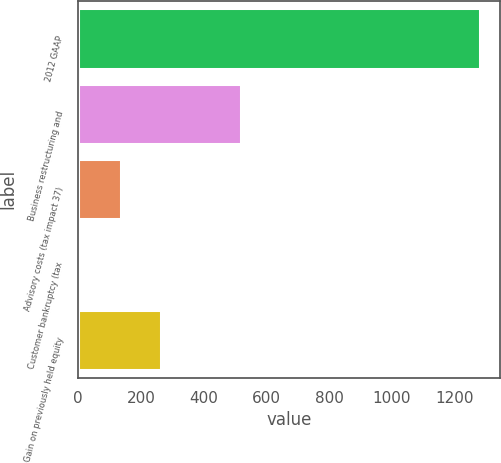Convert chart. <chart><loc_0><loc_0><loc_500><loc_500><bar_chart><fcel>2012 GAAP<fcel>Business restructuring and<fcel>Advisory costs (tax impact 37)<fcel>Customer bankruptcy (tax<fcel>Gain on previously held equity<nl><fcel>1282.4<fcel>518.84<fcel>137.06<fcel>9.8<fcel>264.32<nl></chart> 